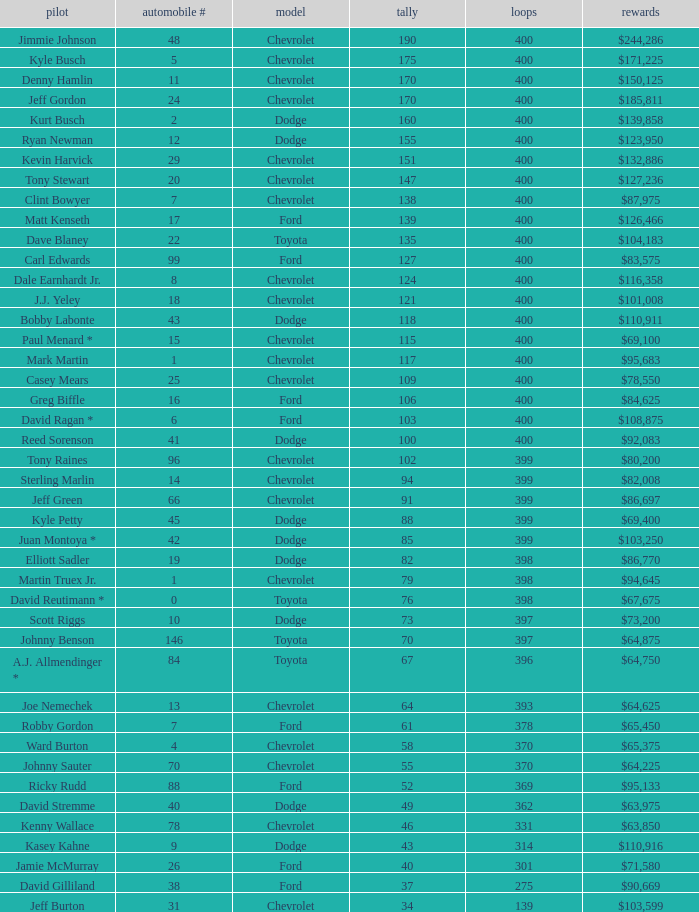What is the car number that has less than 369 laps for a Dodge with more than 49 points? None. 